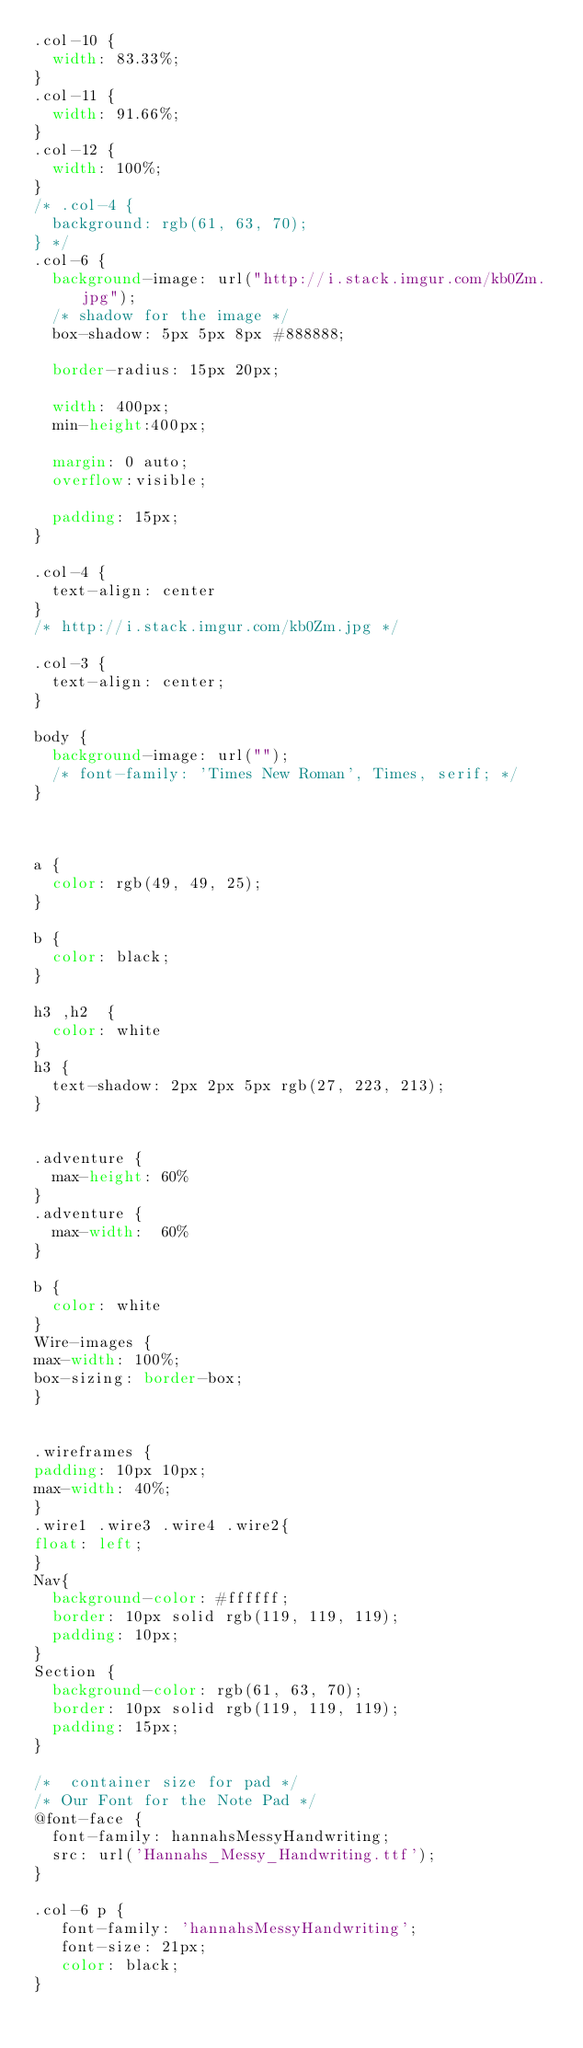<code> <loc_0><loc_0><loc_500><loc_500><_CSS_>.col-10 {
  width: 83.33%;
}
.col-11 {
  width: 91.66%;
}
.col-12 {
  width: 100%;
}
/* .col-4 {
  background: rgb(61, 63, 70);
} */
.col-6 {
  background-image: url("http://i.stack.imgur.com/kb0Zm.jpg");
  /* shadow for the image */
  box-shadow: 5px 5px 8px #888888;

  border-radius: 15px 20px;
  
  width: 400px;
	min-height:400px;

	margin: 0 auto;
  overflow:visible;
  
  padding: 15px;
}

.col-4 {
  text-align: center
}
/* http://i.stack.imgur.com/kb0Zm.jpg */

.col-3 {
  text-align: center;
}

body {
  background-image: url("");
  /* font-family: 'Times New Roman', Times, serif; */
}



a {
  color: rgb(49, 49, 25);
}

b {
  color: black;
}

h3 ,h2  {
  color: white
}
h3 {
  text-shadow: 2px 2px 5px rgb(27, 223, 213);
}


.adventure {
  max-height: 60%
}
.adventure {
  max-width:  60%
}

b {
  color: white
}
Wire-images {
max-width: 100%;
box-sizing: border-box;
}  


.wireframes {
padding: 10px 10px;
max-width: 40%;
}
.wire1 .wire3 .wire4 .wire2{
float: left;
}
Nav{
  background-color: #ffffff;
  border: 10px solid rgb(119, 119, 119);
  padding: 10px;
}
Section {
  background-color: rgb(61, 63, 70);
  border: 10px solid rgb(119, 119, 119);
  padding: 15px;
}

/*  container size for pad */
/* Our Font for the Note Pad */
@font-face {
  font-family: hannahsMessyHandwriting;
  src: url('Hannahs_Messy_Handwriting.ttf');
}

.col-6 p {
   font-family: 'hannahsMessyHandwriting';
   font-size: 21px;
   color: black;
}</code> 